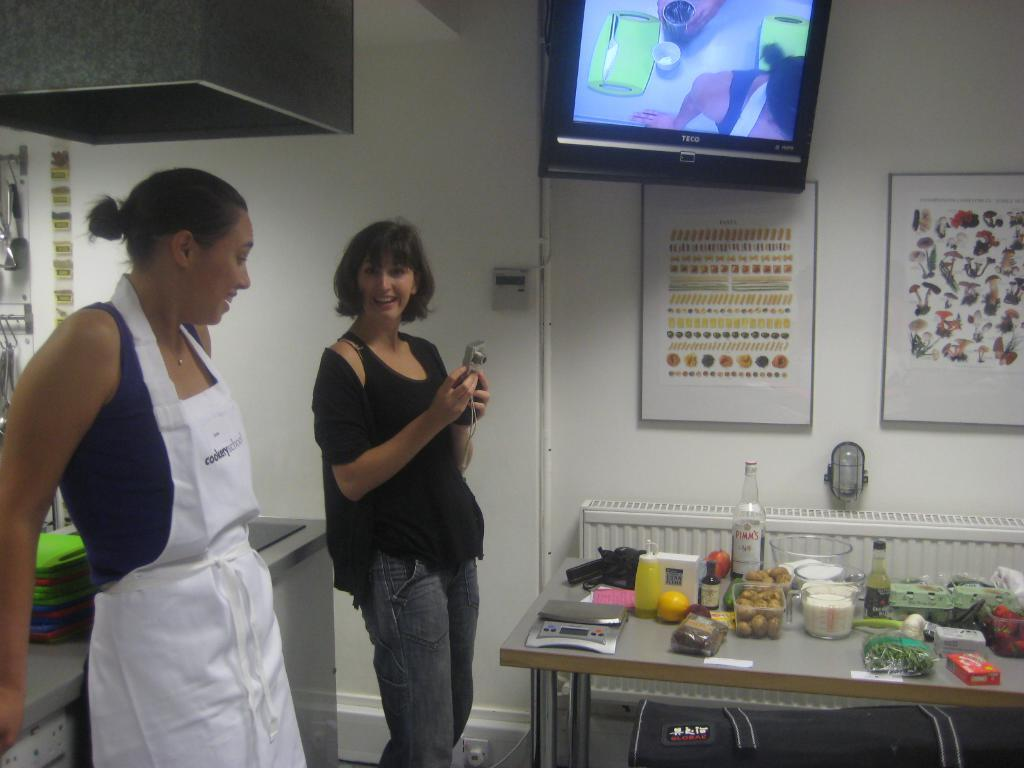Provide a one-sentence caption for the provided image. Two women standing in front of a table with a bottle that saysPimm's. 